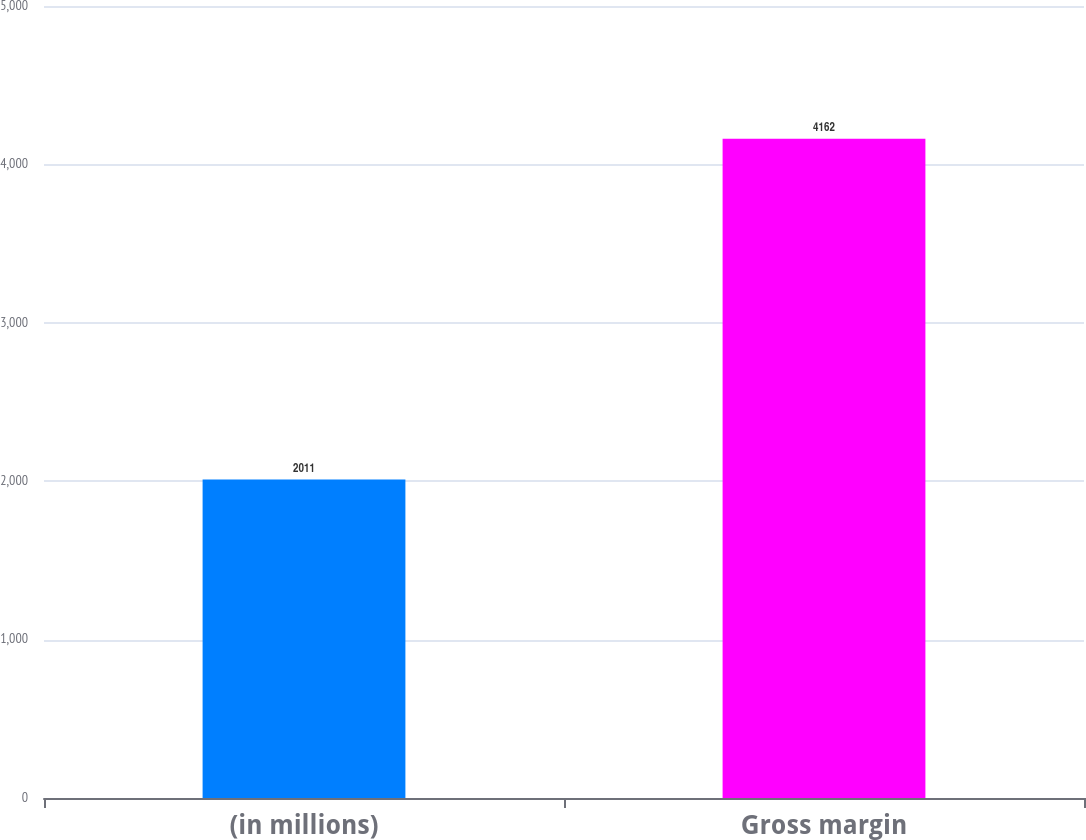Convert chart to OTSL. <chart><loc_0><loc_0><loc_500><loc_500><bar_chart><fcel>(in millions)<fcel>Gross margin<nl><fcel>2011<fcel>4162<nl></chart> 